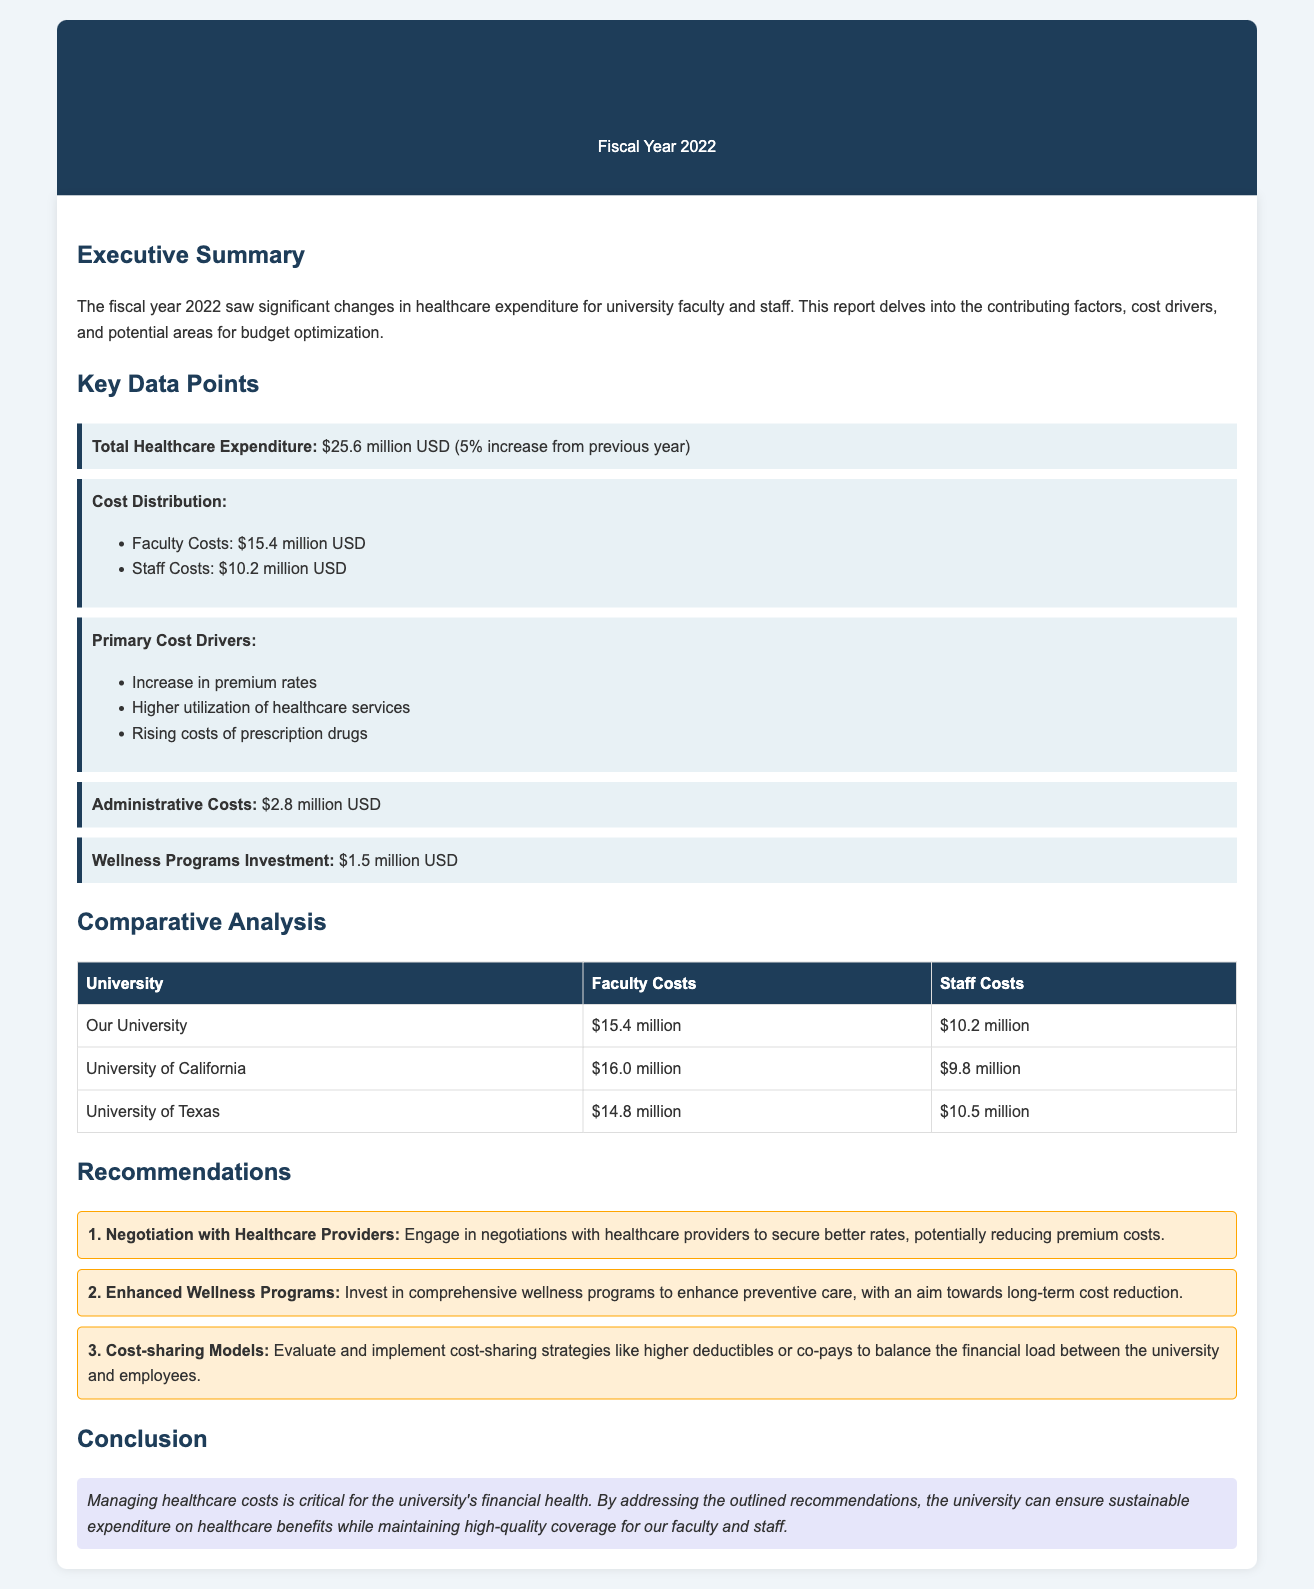what was the total healthcare expenditure for fiscal year 2022? The document states that the total healthcare expenditure for fiscal year 2022 was $25.6 million USD.
Answer: $25.6 million USD what is the administrative costs amount? The document specifies that the administrative costs are $2.8 million USD.
Answer: $2.8 million USD what percentage increase in healthcare costs was reported? The report mentions a 5% increase from the previous year.
Answer: 5% which university had higher faculty costs than ours? The comparative analysis shows that the University of California had higher faculty costs than our university.
Answer: University of California what are the primary cost drivers mentioned? The document lists the primary cost drivers as increase in premium rates, higher utilization of healthcare services, and rising costs of prescription drugs.
Answer: Increase in premium rates, higher utilization of healthcare services, rising costs of prescription drugs what is one recommended action for cost reduction? The document recommends engaging in negotiations with healthcare providers to secure better rates as one potential action.
Answer: Negotiation with Healthcare Providers how much was invested in wellness programs? The wellness programs investment amount is specified as $1.5 million USD in the document.
Answer: $1.5 million USD which university had the lowest staff costs? According to the table, the University of California had the lowest staff costs compared to our university.
Answer: University of California 